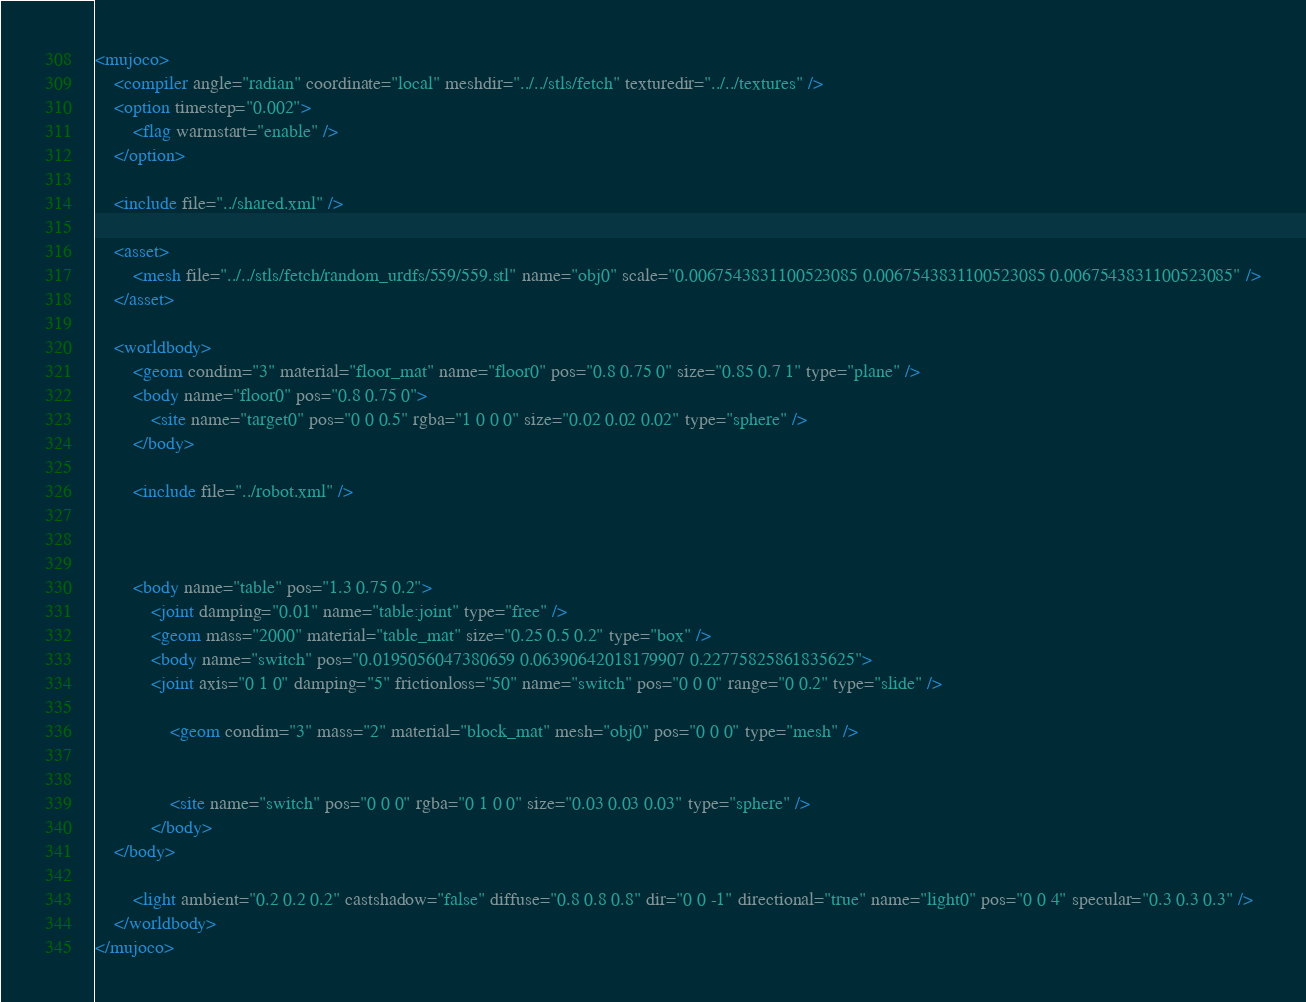<code> <loc_0><loc_0><loc_500><loc_500><_XML_><mujoco>
	<compiler angle="radian" coordinate="local" meshdir="../../stls/fetch" texturedir="../../textures" />
	<option timestep="0.002">
		<flag warmstart="enable" />
	</option>

	<include file="../shared.xml" />

	<asset>
		<mesh file="../../stls/fetch/random_urdfs/559/559.stl" name="obj0" scale="0.0067543831100523085 0.0067543831100523085 0.0067543831100523085" />
	</asset>

	<worldbody>
		<geom condim="3" material="floor_mat" name="floor0" pos="0.8 0.75 0" size="0.85 0.7 1" type="plane" />
		<body name="floor0" pos="0.8 0.75 0">
			<site name="target0" pos="0 0 0.5" rgba="1 0 0 0" size="0.02 0.02 0.02" type="sphere" />
		</body>

		<include file="../robot.xml" />

		

		<body name="table" pos="1.3 0.75 0.2">
			<joint damping="0.01" name="table:joint" type="free" />
			<geom mass="2000" material="table_mat" size="0.25 0.5 0.2" type="box" />
			<body name="switch" pos="0.0195056047380659 0.06390642018179907 0.22775825861835625">
		    <joint axis="0 1 0" damping="5" frictionloss="50" name="switch" pos="0 0 0" range="0 0.2" type="slide" />
				
				<geom condim="3" mass="2" material="block_mat" mesh="obj0" pos="0 0 0" type="mesh" />
				
				
				<site name="switch" pos="0 0 0" rgba="0 1 0 0" size="0.03 0.03 0.03" type="sphere" />
			</body>
    </body>

		<light ambient="0.2 0.2 0.2" castshadow="false" diffuse="0.8 0.8 0.8" dir="0 0 -1" directional="true" name="light0" pos="0 0 4" specular="0.3 0.3 0.3" />
	</worldbody>
</mujoco></code> 